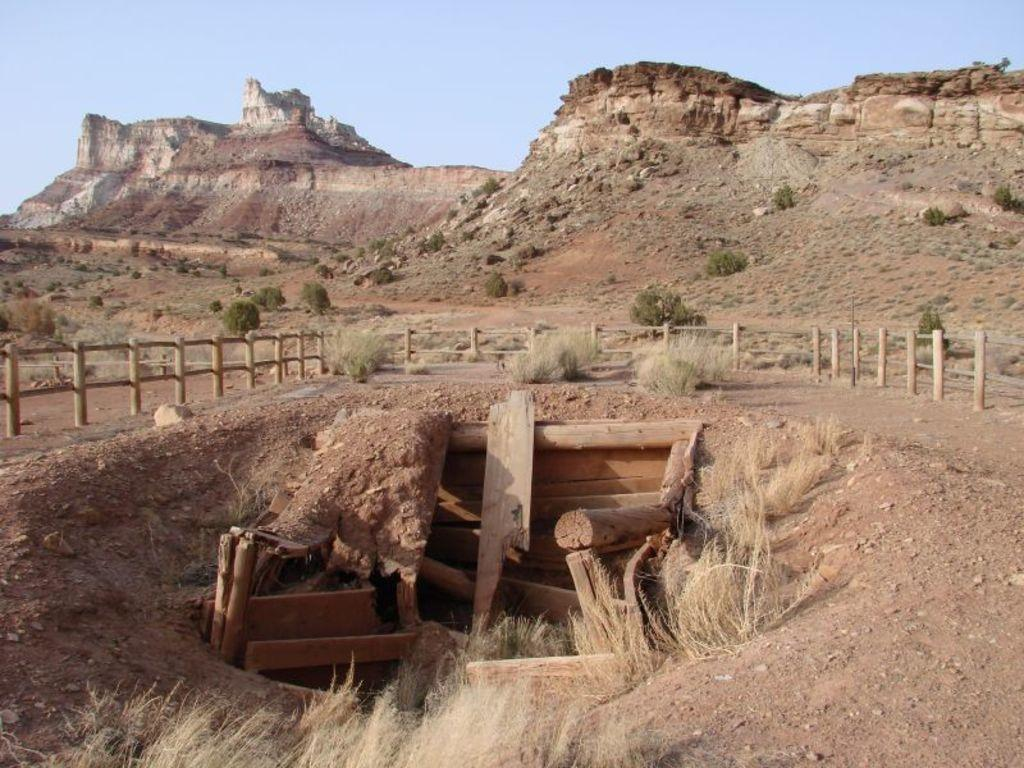What type of material is used to make the logs in the image? The logs in the image are made of wood. What type of vegetation is present in the image? There is grass in the image. What type of barrier can be seen in the image? There is a wooden fence in the image. What can be seen in the distance in the image? Mountains and the sky are visible in the background of the image. What is the weight of the lead group in the image? There is no lead group present in the image, and therefore no weight can be determined. 